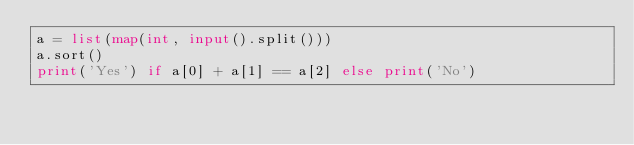Convert code to text. <code><loc_0><loc_0><loc_500><loc_500><_Python_>a = list(map(int, input().split()))
a.sort()
print('Yes') if a[0] + a[1] == a[2] else print('No')</code> 